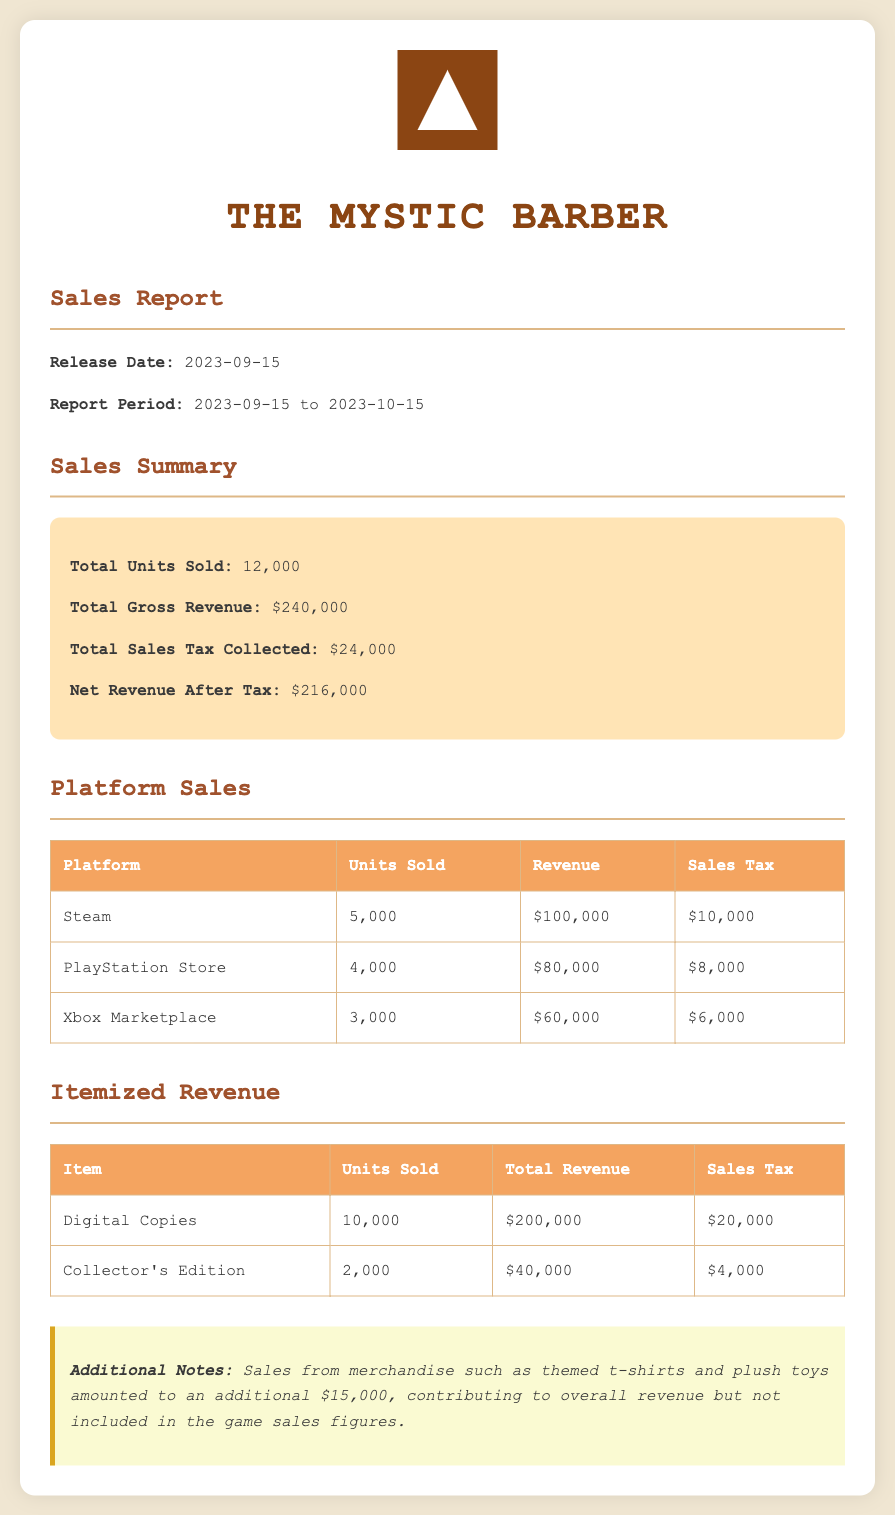what is the total units sold? The total units sold is a summary figure provided in the document, which is 12,000.
Answer: 12,000 what is the total gross revenue? The total gross revenue is the amount generated from sales before tax, which is listed as $240,000.
Answer: $240,000 how much sales tax was collected? The total sales tax collected is a figure that summarizes tax collection, amounting to $24,000.
Answer: $24,000 which platform had the highest revenue? The platform with the highest revenue is identified in the table, which is Steam with $100,000.
Answer: Steam how many units of Collector's Edition were sold? The document provides a specific sales figure for the Collector's Edition, which is 2,000 units.
Answer: 2,000 what was the net revenue after tax? The net revenue after tax is calculated by subtracting sales tax from gross revenue, which is $216,000 as stated in the summary.
Answer: $216,000 total revenue from digital copies? The total revenue from digital copies is explicitly stated in the itemized revenue section, which is $200,000.
Answer: $200,000 how many units were sold through Xbox Marketplace? The number of units sold through the Xbox Marketplace is shown in the platform sales table, which is 3,000.
Answer: 3,000 what is the release date of the game? The release date of the game is specified in the report, which is September 15, 2023.
Answer: 2023-09-15 